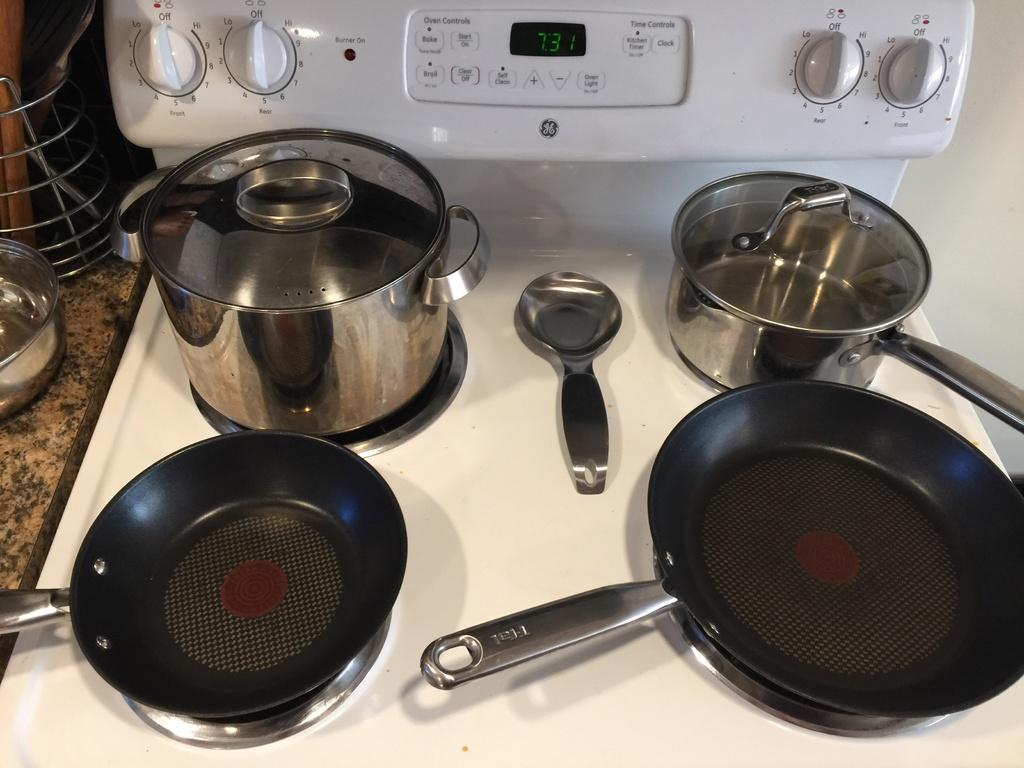<image>
Relay a brief, clear account of the picture shown. a great energy oven with the time reading 7:31 